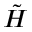Convert formula to latex. <formula><loc_0><loc_0><loc_500><loc_500>\tilde { H }</formula> 